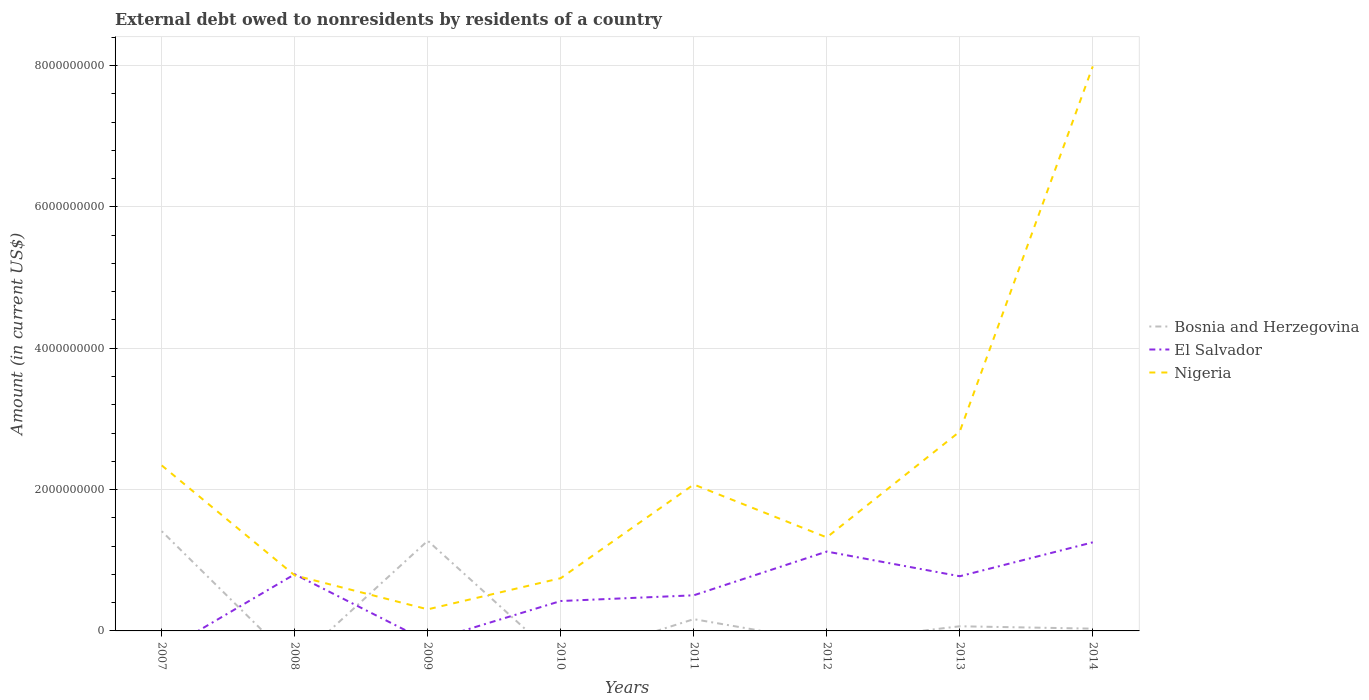How many different coloured lines are there?
Give a very brief answer. 3. Is the number of lines equal to the number of legend labels?
Keep it short and to the point. No. Across all years, what is the maximum external debt owed by residents in El Salvador?
Provide a short and direct response. 0. What is the total external debt owed by residents in El Salvador in the graph?
Your response must be concise. 2.98e+08. What is the difference between the highest and the second highest external debt owed by residents in Nigeria?
Provide a succinct answer. 7.68e+09. What is the difference between the highest and the lowest external debt owed by residents in Nigeria?
Keep it short and to the point. 3. Is the external debt owed by residents in Bosnia and Herzegovina strictly greater than the external debt owed by residents in El Salvador over the years?
Make the answer very short. No. How many lines are there?
Your answer should be compact. 3. How many years are there in the graph?
Your answer should be very brief. 8. Are the values on the major ticks of Y-axis written in scientific E-notation?
Provide a succinct answer. No. Does the graph contain grids?
Give a very brief answer. Yes. Where does the legend appear in the graph?
Your response must be concise. Center right. How many legend labels are there?
Ensure brevity in your answer.  3. What is the title of the graph?
Offer a terse response. External debt owed to nonresidents by residents of a country. Does "Israel" appear as one of the legend labels in the graph?
Provide a short and direct response. No. What is the Amount (in current US$) of Bosnia and Herzegovina in 2007?
Make the answer very short. 1.41e+09. What is the Amount (in current US$) in Nigeria in 2007?
Ensure brevity in your answer.  2.34e+09. What is the Amount (in current US$) of El Salvador in 2008?
Provide a short and direct response. 8.02e+08. What is the Amount (in current US$) of Nigeria in 2008?
Your answer should be compact. 7.86e+08. What is the Amount (in current US$) of Bosnia and Herzegovina in 2009?
Offer a very short reply. 1.28e+09. What is the Amount (in current US$) in El Salvador in 2009?
Provide a short and direct response. 0. What is the Amount (in current US$) in Nigeria in 2009?
Give a very brief answer. 3.05e+08. What is the Amount (in current US$) in El Salvador in 2010?
Provide a short and direct response. 4.23e+08. What is the Amount (in current US$) in Nigeria in 2010?
Offer a very short reply. 7.46e+08. What is the Amount (in current US$) in Bosnia and Herzegovina in 2011?
Ensure brevity in your answer.  1.66e+08. What is the Amount (in current US$) in El Salvador in 2011?
Ensure brevity in your answer.  5.04e+08. What is the Amount (in current US$) in Nigeria in 2011?
Your answer should be very brief. 2.07e+09. What is the Amount (in current US$) in El Salvador in 2012?
Offer a terse response. 1.12e+09. What is the Amount (in current US$) in Nigeria in 2012?
Offer a terse response. 1.32e+09. What is the Amount (in current US$) in Bosnia and Herzegovina in 2013?
Your response must be concise. 6.58e+07. What is the Amount (in current US$) in El Salvador in 2013?
Offer a terse response. 7.74e+08. What is the Amount (in current US$) in Nigeria in 2013?
Ensure brevity in your answer.  2.82e+09. What is the Amount (in current US$) in Bosnia and Herzegovina in 2014?
Provide a short and direct response. 3.21e+07. What is the Amount (in current US$) of El Salvador in 2014?
Your answer should be compact. 1.25e+09. What is the Amount (in current US$) of Nigeria in 2014?
Provide a short and direct response. 7.99e+09. Across all years, what is the maximum Amount (in current US$) in Bosnia and Herzegovina?
Give a very brief answer. 1.41e+09. Across all years, what is the maximum Amount (in current US$) in El Salvador?
Offer a very short reply. 1.25e+09. Across all years, what is the maximum Amount (in current US$) in Nigeria?
Provide a succinct answer. 7.99e+09. Across all years, what is the minimum Amount (in current US$) of Nigeria?
Provide a short and direct response. 3.05e+08. What is the total Amount (in current US$) in Bosnia and Herzegovina in the graph?
Ensure brevity in your answer.  2.95e+09. What is the total Amount (in current US$) of El Salvador in the graph?
Provide a succinct answer. 4.88e+09. What is the total Amount (in current US$) of Nigeria in the graph?
Provide a succinct answer. 1.84e+1. What is the difference between the Amount (in current US$) of Nigeria in 2007 and that in 2008?
Your response must be concise. 1.56e+09. What is the difference between the Amount (in current US$) of Bosnia and Herzegovina in 2007 and that in 2009?
Your answer should be compact. 1.35e+08. What is the difference between the Amount (in current US$) of Nigeria in 2007 and that in 2009?
Give a very brief answer. 2.04e+09. What is the difference between the Amount (in current US$) in Nigeria in 2007 and that in 2010?
Keep it short and to the point. 1.60e+09. What is the difference between the Amount (in current US$) in Bosnia and Herzegovina in 2007 and that in 2011?
Offer a terse response. 1.24e+09. What is the difference between the Amount (in current US$) in Nigeria in 2007 and that in 2011?
Offer a terse response. 2.70e+08. What is the difference between the Amount (in current US$) in Nigeria in 2007 and that in 2012?
Make the answer very short. 1.02e+09. What is the difference between the Amount (in current US$) in Bosnia and Herzegovina in 2007 and that in 2013?
Offer a terse response. 1.35e+09. What is the difference between the Amount (in current US$) of Nigeria in 2007 and that in 2013?
Your answer should be very brief. -4.79e+08. What is the difference between the Amount (in current US$) in Bosnia and Herzegovina in 2007 and that in 2014?
Offer a very short reply. 1.38e+09. What is the difference between the Amount (in current US$) in Nigeria in 2007 and that in 2014?
Provide a short and direct response. -5.65e+09. What is the difference between the Amount (in current US$) of Nigeria in 2008 and that in 2009?
Offer a very short reply. 4.80e+08. What is the difference between the Amount (in current US$) in El Salvador in 2008 and that in 2010?
Keep it short and to the point. 3.79e+08. What is the difference between the Amount (in current US$) in Nigeria in 2008 and that in 2010?
Your answer should be very brief. 3.94e+07. What is the difference between the Amount (in current US$) of El Salvador in 2008 and that in 2011?
Provide a succinct answer. 2.98e+08. What is the difference between the Amount (in current US$) in Nigeria in 2008 and that in 2011?
Offer a terse response. -1.29e+09. What is the difference between the Amount (in current US$) of El Salvador in 2008 and that in 2012?
Keep it short and to the point. -3.21e+08. What is the difference between the Amount (in current US$) in Nigeria in 2008 and that in 2012?
Make the answer very short. -5.38e+08. What is the difference between the Amount (in current US$) of El Salvador in 2008 and that in 2013?
Provide a short and direct response. 2.82e+07. What is the difference between the Amount (in current US$) of Nigeria in 2008 and that in 2013?
Your answer should be very brief. -2.04e+09. What is the difference between the Amount (in current US$) in El Salvador in 2008 and that in 2014?
Give a very brief answer. -4.52e+08. What is the difference between the Amount (in current US$) in Nigeria in 2008 and that in 2014?
Give a very brief answer. -7.20e+09. What is the difference between the Amount (in current US$) of Nigeria in 2009 and that in 2010?
Provide a succinct answer. -4.41e+08. What is the difference between the Amount (in current US$) in Bosnia and Herzegovina in 2009 and that in 2011?
Provide a short and direct response. 1.11e+09. What is the difference between the Amount (in current US$) in Nigeria in 2009 and that in 2011?
Your response must be concise. -1.77e+09. What is the difference between the Amount (in current US$) in Nigeria in 2009 and that in 2012?
Keep it short and to the point. -1.02e+09. What is the difference between the Amount (in current US$) in Bosnia and Herzegovina in 2009 and that in 2013?
Provide a short and direct response. 1.21e+09. What is the difference between the Amount (in current US$) in Nigeria in 2009 and that in 2013?
Offer a very short reply. -2.52e+09. What is the difference between the Amount (in current US$) of Bosnia and Herzegovina in 2009 and that in 2014?
Provide a short and direct response. 1.24e+09. What is the difference between the Amount (in current US$) of Nigeria in 2009 and that in 2014?
Make the answer very short. -7.68e+09. What is the difference between the Amount (in current US$) of El Salvador in 2010 and that in 2011?
Keep it short and to the point. -8.06e+07. What is the difference between the Amount (in current US$) of Nigeria in 2010 and that in 2011?
Give a very brief answer. -1.33e+09. What is the difference between the Amount (in current US$) of El Salvador in 2010 and that in 2012?
Your answer should be very brief. -7.00e+08. What is the difference between the Amount (in current US$) of Nigeria in 2010 and that in 2012?
Provide a succinct answer. -5.77e+08. What is the difference between the Amount (in current US$) of El Salvador in 2010 and that in 2013?
Offer a terse response. -3.50e+08. What is the difference between the Amount (in current US$) of Nigeria in 2010 and that in 2013?
Give a very brief answer. -2.07e+09. What is the difference between the Amount (in current US$) in El Salvador in 2010 and that in 2014?
Your response must be concise. -8.30e+08. What is the difference between the Amount (in current US$) of Nigeria in 2010 and that in 2014?
Your response must be concise. -7.24e+09. What is the difference between the Amount (in current US$) of El Salvador in 2011 and that in 2012?
Offer a very short reply. -6.19e+08. What is the difference between the Amount (in current US$) of Nigeria in 2011 and that in 2012?
Your answer should be very brief. 7.49e+08. What is the difference between the Amount (in current US$) in Bosnia and Herzegovina in 2011 and that in 2013?
Provide a succinct answer. 1.01e+08. What is the difference between the Amount (in current US$) in El Salvador in 2011 and that in 2013?
Your answer should be very brief. -2.70e+08. What is the difference between the Amount (in current US$) in Nigeria in 2011 and that in 2013?
Provide a short and direct response. -7.49e+08. What is the difference between the Amount (in current US$) of Bosnia and Herzegovina in 2011 and that in 2014?
Give a very brief answer. 1.34e+08. What is the difference between the Amount (in current US$) of El Salvador in 2011 and that in 2014?
Offer a very short reply. -7.50e+08. What is the difference between the Amount (in current US$) of Nigeria in 2011 and that in 2014?
Keep it short and to the point. -5.92e+09. What is the difference between the Amount (in current US$) in El Salvador in 2012 and that in 2013?
Your answer should be compact. 3.49e+08. What is the difference between the Amount (in current US$) in Nigeria in 2012 and that in 2013?
Offer a very short reply. -1.50e+09. What is the difference between the Amount (in current US$) in El Salvador in 2012 and that in 2014?
Offer a terse response. -1.30e+08. What is the difference between the Amount (in current US$) of Nigeria in 2012 and that in 2014?
Ensure brevity in your answer.  -6.66e+09. What is the difference between the Amount (in current US$) of Bosnia and Herzegovina in 2013 and that in 2014?
Provide a short and direct response. 3.37e+07. What is the difference between the Amount (in current US$) of El Salvador in 2013 and that in 2014?
Your answer should be compact. -4.80e+08. What is the difference between the Amount (in current US$) of Nigeria in 2013 and that in 2014?
Your answer should be very brief. -5.17e+09. What is the difference between the Amount (in current US$) of Bosnia and Herzegovina in 2007 and the Amount (in current US$) of El Salvador in 2008?
Offer a very short reply. 6.09e+08. What is the difference between the Amount (in current US$) in Bosnia and Herzegovina in 2007 and the Amount (in current US$) in Nigeria in 2008?
Offer a terse response. 6.25e+08. What is the difference between the Amount (in current US$) in Bosnia and Herzegovina in 2007 and the Amount (in current US$) in Nigeria in 2009?
Keep it short and to the point. 1.11e+09. What is the difference between the Amount (in current US$) of Bosnia and Herzegovina in 2007 and the Amount (in current US$) of El Salvador in 2010?
Your answer should be compact. 9.88e+08. What is the difference between the Amount (in current US$) of Bosnia and Herzegovina in 2007 and the Amount (in current US$) of Nigeria in 2010?
Keep it short and to the point. 6.65e+08. What is the difference between the Amount (in current US$) of Bosnia and Herzegovina in 2007 and the Amount (in current US$) of El Salvador in 2011?
Provide a short and direct response. 9.07e+08. What is the difference between the Amount (in current US$) of Bosnia and Herzegovina in 2007 and the Amount (in current US$) of Nigeria in 2011?
Provide a succinct answer. -6.61e+08. What is the difference between the Amount (in current US$) of Bosnia and Herzegovina in 2007 and the Amount (in current US$) of El Salvador in 2012?
Provide a short and direct response. 2.88e+08. What is the difference between the Amount (in current US$) of Bosnia and Herzegovina in 2007 and the Amount (in current US$) of Nigeria in 2012?
Provide a short and direct response. 8.79e+07. What is the difference between the Amount (in current US$) of Bosnia and Herzegovina in 2007 and the Amount (in current US$) of El Salvador in 2013?
Ensure brevity in your answer.  6.37e+08. What is the difference between the Amount (in current US$) of Bosnia and Herzegovina in 2007 and the Amount (in current US$) of Nigeria in 2013?
Offer a terse response. -1.41e+09. What is the difference between the Amount (in current US$) in Bosnia and Herzegovina in 2007 and the Amount (in current US$) in El Salvador in 2014?
Keep it short and to the point. 1.58e+08. What is the difference between the Amount (in current US$) of Bosnia and Herzegovina in 2007 and the Amount (in current US$) of Nigeria in 2014?
Provide a succinct answer. -6.58e+09. What is the difference between the Amount (in current US$) of El Salvador in 2008 and the Amount (in current US$) of Nigeria in 2009?
Your answer should be compact. 4.96e+08. What is the difference between the Amount (in current US$) in El Salvador in 2008 and the Amount (in current US$) in Nigeria in 2010?
Make the answer very short. 5.55e+07. What is the difference between the Amount (in current US$) of El Salvador in 2008 and the Amount (in current US$) of Nigeria in 2011?
Provide a short and direct response. -1.27e+09. What is the difference between the Amount (in current US$) of El Salvador in 2008 and the Amount (in current US$) of Nigeria in 2012?
Give a very brief answer. -5.21e+08. What is the difference between the Amount (in current US$) in El Salvador in 2008 and the Amount (in current US$) in Nigeria in 2013?
Make the answer very short. -2.02e+09. What is the difference between the Amount (in current US$) in El Salvador in 2008 and the Amount (in current US$) in Nigeria in 2014?
Give a very brief answer. -7.19e+09. What is the difference between the Amount (in current US$) in Bosnia and Herzegovina in 2009 and the Amount (in current US$) in El Salvador in 2010?
Give a very brief answer. 8.53e+08. What is the difference between the Amount (in current US$) in Bosnia and Herzegovina in 2009 and the Amount (in current US$) in Nigeria in 2010?
Keep it short and to the point. 5.30e+08. What is the difference between the Amount (in current US$) in Bosnia and Herzegovina in 2009 and the Amount (in current US$) in El Salvador in 2011?
Your answer should be very brief. 7.72e+08. What is the difference between the Amount (in current US$) in Bosnia and Herzegovina in 2009 and the Amount (in current US$) in Nigeria in 2011?
Make the answer very short. -7.96e+08. What is the difference between the Amount (in current US$) in Bosnia and Herzegovina in 2009 and the Amount (in current US$) in El Salvador in 2012?
Your response must be concise. 1.53e+08. What is the difference between the Amount (in current US$) of Bosnia and Herzegovina in 2009 and the Amount (in current US$) of Nigeria in 2012?
Your answer should be compact. -4.72e+07. What is the difference between the Amount (in current US$) in Bosnia and Herzegovina in 2009 and the Amount (in current US$) in El Salvador in 2013?
Offer a terse response. 5.02e+08. What is the difference between the Amount (in current US$) of Bosnia and Herzegovina in 2009 and the Amount (in current US$) of Nigeria in 2013?
Provide a succinct answer. -1.54e+09. What is the difference between the Amount (in current US$) in Bosnia and Herzegovina in 2009 and the Amount (in current US$) in El Salvador in 2014?
Your answer should be compact. 2.27e+07. What is the difference between the Amount (in current US$) in Bosnia and Herzegovina in 2009 and the Amount (in current US$) in Nigeria in 2014?
Your response must be concise. -6.71e+09. What is the difference between the Amount (in current US$) of El Salvador in 2010 and the Amount (in current US$) of Nigeria in 2011?
Offer a very short reply. -1.65e+09. What is the difference between the Amount (in current US$) in El Salvador in 2010 and the Amount (in current US$) in Nigeria in 2012?
Your answer should be very brief. -9.00e+08. What is the difference between the Amount (in current US$) of El Salvador in 2010 and the Amount (in current US$) of Nigeria in 2013?
Provide a short and direct response. -2.40e+09. What is the difference between the Amount (in current US$) of El Salvador in 2010 and the Amount (in current US$) of Nigeria in 2014?
Give a very brief answer. -7.56e+09. What is the difference between the Amount (in current US$) in Bosnia and Herzegovina in 2011 and the Amount (in current US$) in El Salvador in 2012?
Make the answer very short. -9.56e+08. What is the difference between the Amount (in current US$) in Bosnia and Herzegovina in 2011 and the Amount (in current US$) in Nigeria in 2012?
Ensure brevity in your answer.  -1.16e+09. What is the difference between the Amount (in current US$) of El Salvador in 2011 and the Amount (in current US$) of Nigeria in 2012?
Offer a very short reply. -8.19e+08. What is the difference between the Amount (in current US$) of Bosnia and Herzegovina in 2011 and the Amount (in current US$) of El Salvador in 2013?
Make the answer very short. -6.07e+08. What is the difference between the Amount (in current US$) of Bosnia and Herzegovina in 2011 and the Amount (in current US$) of Nigeria in 2013?
Offer a very short reply. -2.65e+09. What is the difference between the Amount (in current US$) in El Salvador in 2011 and the Amount (in current US$) in Nigeria in 2013?
Keep it short and to the point. -2.32e+09. What is the difference between the Amount (in current US$) in Bosnia and Herzegovina in 2011 and the Amount (in current US$) in El Salvador in 2014?
Your response must be concise. -1.09e+09. What is the difference between the Amount (in current US$) of Bosnia and Herzegovina in 2011 and the Amount (in current US$) of Nigeria in 2014?
Provide a succinct answer. -7.82e+09. What is the difference between the Amount (in current US$) in El Salvador in 2011 and the Amount (in current US$) in Nigeria in 2014?
Ensure brevity in your answer.  -7.48e+09. What is the difference between the Amount (in current US$) in El Salvador in 2012 and the Amount (in current US$) in Nigeria in 2013?
Provide a short and direct response. -1.70e+09. What is the difference between the Amount (in current US$) in El Salvador in 2012 and the Amount (in current US$) in Nigeria in 2014?
Ensure brevity in your answer.  -6.86e+09. What is the difference between the Amount (in current US$) of Bosnia and Herzegovina in 2013 and the Amount (in current US$) of El Salvador in 2014?
Your response must be concise. -1.19e+09. What is the difference between the Amount (in current US$) of Bosnia and Herzegovina in 2013 and the Amount (in current US$) of Nigeria in 2014?
Make the answer very short. -7.92e+09. What is the difference between the Amount (in current US$) in El Salvador in 2013 and the Amount (in current US$) in Nigeria in 2014?
Keep it short and to the point. -7.21e+09. What is the average Amount (in current US$) of Bosnia and Herzegovina per year?
Your response must be concise. 3.69e+08. What is the average Amount (in current US$) of El Salvador per year?
Provide a short and direct response. 6.10e+08. What is the average Amount (in current US$) of Nigeria per year?
Keep it short and to the point. 2.30e+09. In the year 2007, what is the difference between the Amount (in current US$) in Bosnia and Herzegovina and Amount (in current US$) in Nigeria?
Keep it short and to the point. -9.31e+08. In the year 2008, what is the difference between the Amount (in current US$) in El Salvador and Amount (in current US$) in Nigeria?
Keep it short and to the point. 1.61e+07. In the year 2009, what is the difference between the Amount (in current US$) in Bosnia and Herzegovina and Amount (in current US$) in Nigeria?
Provide a short and direct response. 9.71e+08. In the year 2010, what is the difference between the Amount (in current US$) of El Salvador and Amount (in current US$) of Nigeria?
Give a very brief answer. -3.23e+08. In the year 2011, what is the difference between the Amount (in current US$) of Bosnia and Herzegovina and Amount (in current US$) of El Salvador?
Offer a terse response. -3.37e+08. In the year 2011, what is the difference between the Amount (in current US$) of Bosnia and Herzegovina and Amount (in current US$) of Nigeria?
Your answer should be very brief. -1.91e+09. In the year 2011, what is the difference between the Amount (in current US$) in El Salvador and Amount (in current US$) in Nigeria?
Your response must be concise. -1.57e+09. In the year 2012, what is the difference between the Amount (in current US$) in El Salvador and Amount (in current US$) in Nigeria?
Ensure brevity in your answer.  -2.00e+08. In the year 2013, what is the difference between the Amount (in current US$) in Bosnia and Herzegovina and Amount (in current US$) in El Salvador?
Your answer should be very brief. -7.08e+08. In the year 2013, what is the difference between the Amount (in current US$) in Bosnia and Herzegovina and Amount (in current US$) in Nigeria?
Ensure brevity in your answer.  -2.76e+09. In the year 2013, what is the difference between the Amount (in current US$) in El Salvador and Amount (in current US$) in Nigeria?
Provide a succinct answer. -2.05e+09. In the year 2014, what is the difference between the Amount (in current US$) of Bosnia and Herzegovina and Amount (in current US$) of El Salvador?
Provide a succinct answer. -1.22e+09. In the year 2014, what is the difference between the Amount (in current US$) of Bosnia and Herzegovina and Amount (in current US$) of Nigeria?
Make the answer very short. -7.96e+09. In the year 2014, what is the difference between the Amount (in current US$) in El Salvador and Amount (in current US$) in Nigeria?
Provide a succinct answer. -6.73e+09. What is the ratio of the Amount (in current US$) in Nigeria in 2007 to that in 2008?
Your answer should be compact. 2.98. What is the ratio of the Amount (in current US$) of Bosnia and Herzegovina in 2007 to that in 2009?
Your response must be concise. 1.11. What is the ratio of the Amount (in current US$) in Nigeria in 2007 to that in 2009?
Your answer should be very brief. 7.67. What is the ratio of the Amount (in current US$) of Nigeria in 2007 to that in 2010?
Keep it short and to the point. 3.14. What is the ratio of the Amount (in current US$) in Bosnia and Herzegovina in 2007 to that in 2011?
Keep it short and to the point. 8.48. What is the ratio of the Amount (in current US$) of Nigeria in 2007 to that in 2011?
Provide a succinct answer. 1.13. What is the ratio of the Amount (in current US$) of Nigeria in 2007 to that in 2012?
Your response must be concise. 1.77. What is the ratio of the Amount (in current US$) in Bosnia and Herzegovina in 2007 to that in 2013?
Make the answer very short. 21.45. What is the ratio of the Amount (in current US$) of Nigeria in 2007 to that in 2013?
Ensure brevity in your answer.  0.83. What is the ratio of the Amount (in current US$) in Bosnia and Herzegovina in 2007 to that in 2014?
Provide a succinct answer. 43.99. What is the ratio of the Amount (in current US$) in Nigeria in 2007 to that in 2014?
Provide a short and direct response. 0.29. What is the ratio of the Amount (in current US$) in Nigeria in 2008 to that in 2009?
Your answer should be compact. 2.57. What is the ratio of the Amount (in current US$) of El Salvador in 2008 to that in 2010?
Ensure brevity in your answer.  1.89. What is the ratio of the Amount (in current US$) in Nigeria in 2008 to that in 2010?
Provide a succinct answer. 1.05. What is the ratio of the Amount (in current US$) of El Salvador in 2008 to that in 2011?
Keep it short and to the point. 1.59. What is the ratio of the Amount (in current US$) of Nigeria in 2008 to that in 2011?
Provide a succinct answer. 0.38. What is the ratio of the Amount (in current US$) of El Salvador in 2008 to that in 2012?
Provide a succinct answer. 0.71. What is the ratio of the Amount (in current US$) of Nigeria in 2008 to that in 2012?
Provide a short and direct response. 0.59. What is the ratio of the Amount (in current US$) of El Salvador in 2008 to that in 2013?
Offer a very short reply. 1.04. What is the ratio of the Amount (in current US$) in Nigeria in 2008 to that in 2013?
Keep it short and to the point. 0.28. What is the ratio of the Amount (in current US$) of El Salvador in 2008 to that in 2014?
Your answer should be very brief. 0.64. What is the ratio of the Amount (in current US$) of Nigeria in 2008 to that in 2014?
Keep it short and to the point. 0.1. What is the ratio of the Amount (in current US$) in Nigeria in 2009 to that in 2010?
Offer a terse response. 0.41. What is the ratio of the Amount (in current US$) of Bosnia and Herzegovina in 2009 to that in 2011?
Provide a succinct answer. 7.67. What is the ratio of the Amount (in current US$) of Nigeria in 2009 to that in 2011?
Your answer should be very brief. 0.15. What is the ratio of the Amount (in current US$) in Nigeria in 2009 to that in 2012?
Provide a short and direct response. 0.23. What is the ratio of the Amount (in current US$) in Bosnia and Herzegovina in 2009 to that in 2013?
Offer a terse response. 19.39. What is the ratio of the Amount (in current US$) of Nigeria in 2009 to that in 2013?
Your response must be concise. 0.11. What is the ratio of the Amount (in current US$) in Bosnia and Herzegovina in 2009 to that in 2014?
Your answer should be compact. 39.78. What is the ratio of the Amount (in current US$) in Nigeria in 2009 to that in 2014?
Offer a very short reply. 0.04. What is the ratio of the Amount (in current US$) in El Salvador in 2010 to that in 2011?
Give a very brief answer. 0.84. What is the ratio of the Amount (in current US$) of Nigeria in 2010 to that in 2011?
Make the answer very short. 0.36. What is the ratio of the Amount (in current US$) of El Salvador in 2010 to that in 2012?
Your answer should be very brief. 0.38. What is the ratio of the Amount (in current US$) in Nigeria in 2010 to that in 2012?
Your answer should be compact. 0.56. What is the ratio of the Amount (in current US$) of El Salvador in 2010 to that in 2013?
Offer a terse response. 0.55. What is the ratio of the Amount (in current US$) in Nigeria in 2010 to that in 2013?
Your response must be concise. 0.26. What is the ratio of the Amount (in current US$) in El Salvador in 2010 to that in 2014?
Your response must be concise. 0.34. What is the ratio of the Amount (in current US$) of Nigeria in 2010 to that in 2014?
Your answer should be very brief. 0.09. What is the ratio of the Amount (in current US$) of El Salvador in 2011 to that in 2012?
Your answer should be compact. 0.45. What is the ratio of the Amount (in current US$) in Nigeria in 2011 to that in 2012?
Make the answer very short. 1.57. What is the ratio of the Amount (in current US$) of Bosnia and Herzegovina in 2011 to that in 2013?
Keep it short and to the point. 2.53. What is the ratio of the Amount (in current US$) of El Salvador in 2011 to that in 2013?
Provide a short and direct response. 0.65. What is the ratio of the Amount (in current US$) of Nigeria in 2011 to that in 2013?
Keep it short and to the point. 0.73. What is the ratio of the Amount (in current US$) of Bosnia and Herzegovina in 2011 to that in 2014?
Your answer should be very brief. 5.19. What is the ratio of the Amount (in current US$) in El Salvador in 2011 to that in 2014?
Provide a short and direct response. 0.4. What is the ratio of the Amount (in current US$) in Nigeria in 2011 to that in 2014?
Provide a short and direct response. 0.26. What is the ratio of the Amount (in current US$) of El Salvador in 2012 to that in 2013?
Offer a terse response. 1.45. What is the ratio of the Amount (in current US$) in Nigeria in 2012 to that in 2013?
Provide a short and direct response. 0.47. What is the ratio of the Amount (in current US$) in El Salvador in 2012 to that in 2014?
Keep it short and to the point. 0.9. What is the ratio of the Amount (in current US$) of Nigeria in 2012 to that in 2014?
Keep it short and to the point. 0.17. What is the ratio of the Amount (in current US$) of Bosnia and Herzegovina in 2013 to that in 2014?
Make the answer very short. 2.05. What is the ratio of the Amount (in current US$) in El Salvador in 2013 to that in 2014?
Your answer should be compact. 0.62. What is the ratio of the Amount (in current US$) in Nigeria in 2013 to that in 2014?
Your answer should be very brief. 0.35. What is the difference between the highest and the second highest Amount (in current US$) of Bosnia and Herzegovina?
Offer a very short reply. 1.35e+08. What is the difference between the highest and the second highest Amount (in current US$) in El Salvador?
Make the answer very short. 1.30e+08. What is the difference between the highest and the second highest Amount (in current US$) in Nigeria?
Your response must be concise. 5.17e+09. What is the difference between the highest and the lowest Amount (in current US$) in Bosnia and Herzegovina?
Provide a succinct answer. 1.41e+09. What is the difference between the highest and the lowest Amount (in current US$) of El Salvador?
Your answer should be very brief. 1.25e+09. What is the difference between the highest and the lowest Amount (in current US$) of Nigeria?
Provide a succinct answer. 7.68e+09. 